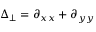Convert formula to latex. <formula><loc_0><loc_0><loc_500><loc_500>\Delta _ { \perp } = \partial _ { x x } + \partial _ { y y }</formula> 